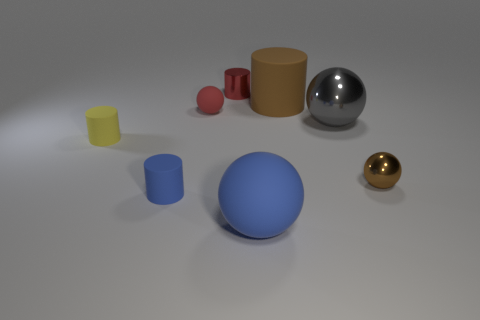Add 2 large brown objects. How many objects exist? 10 Add 2 tiny brown objects. How many tiny brown objects are left? 3 Add 2 small blue rubber cylinders. How many small blue rubber cylinders exist? 3 Subtract 0 cyan spheres. How many objects are left? 8 Subtract all tiny blue matte cylinders. Subtract all small purple metal cubes. How many objects are left? 7 